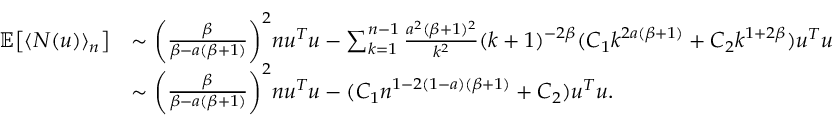Convert formula to latex. <formula><loc_0><loc_0><loc_500><loc_500>\begin{array} { r l } { \mathbb { E } \left [ \langle N ( u ) \rangle _ { n } \right ] } & { \sim \left ( \frac { \beta } { \beta - a ( \beta + 1 ) } \right ) ^ { 2 } n u ^ { T } u - \sum _ { k = 1 } ^ { n - 1 } \frac { a ^ { 2 } ( \beta + 1 ) ^ { 2 } } { k ^ { 2 } } ( k + 1 ) ^ { - 2 \beta } ( C _ { 1 } k ^ { 2 a ( \beta + 1 ) } + C _ { 2 } k ^ { 1 + 2 \beta } ) u ^ { T } u } \\ & { \sim \left ( \frac { \beta } { \beta - a ( \beta + 1 ) } \right ) ^ { 2 } n u ^ { T } u - ( C _ { 1 } n ^ { 1 - 2 ( 1 - a ) ( \beta + 1 ) } + C _ { 2 } ) u ^ { T } u . } \end{array}</formula> 